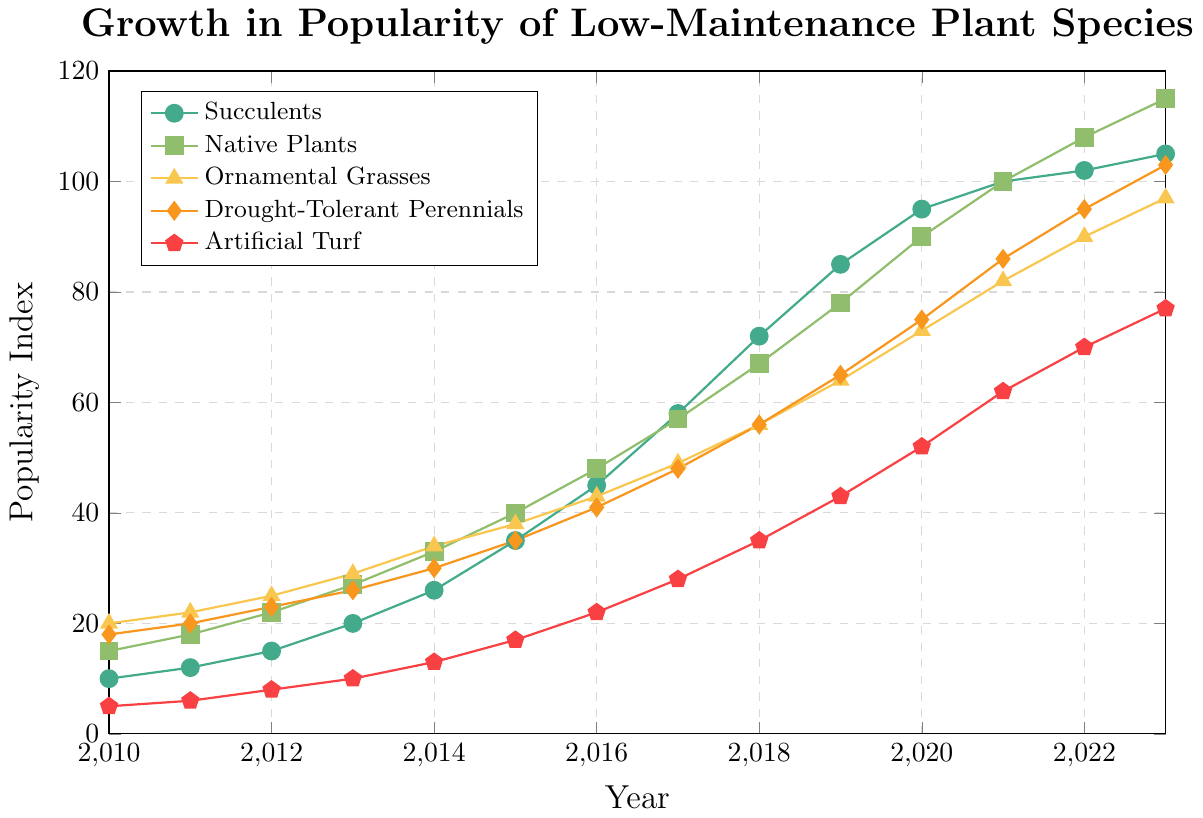Which plant species had the highest popularity index in 2023? Look at the values for 2023 for each species and compare their popularity indices. Native Plants have the highest index at 115.
Answer: Native Plants How did the popularity of Succulents change from 2010 to 2023? Subtract the 2010 popularity index from the 2023 value: 105 - 10 = 95.
Answer: Increased by 95 Which plant species had the least growth in popularity from 2010 to 2023? Calculate the change for each species and compare. Succulents: 105-10=95, Native Plants: 115-15=100, Ornamental Grasses: 97-20=77, Drought-Tolerant Perennials: 103-18=85, Artificial Turf: 77-5=72. Artificial Turf had the smallest growth.
Answer: Artificial Turf What is the average popularity of Drought-Tolerant Perennials from 2010 to 2023? Add up the values from all years and divide by the number of years (14): (18+20+23+26+30+35+41+48+56+65+75+86+95+103)/14 = 49.6.
Answer: 49.6 During which year did Native Plants surpass a popularity index of 50? Look at the values for Native Plants and find the first year where the index is above 50. In 2016, the index is 48, and in 2017, it is 57.
Answer: 2017 Which species showed the steepest increase between 2015 and 2016? Calculate the change for each species between 2015 and 2016: Succulents: 45-35=10, Native Plants: 48-40=8, Ornamental Grasses: 43-38=5, Drought-Tolerant Perennials: 41-35=6, Artificial Turf: 22-17=5. Succulents have the largest increase.
Answer: Succulents From 2010 to 2023, which year had the highest overall increase in popularity index for all species combined? Calculate the sum of increases for all species for each year and identify the highest. 
For example, between 2010 and 2011: (12-10) + (18-15) + (22-20) + (20-18) + (6-5) = 3 + 3 + 2 + 2 + 1 = 11.
Repeat this for all years and find the highest sum.
Between 2016 and 2017: 13 + 9 + 6 + 7 + 6 = 41.
Answer: 2016-2017 What is the combined popularity index of all species in 2010? Add the popularity indices for all species in 2010: 10 + 15 + 20 + 18 + 5 = 68.
Answer: 68 Which species had the most consistent growth from 2010 to 2023, based on visual analysis? Visually assess the steadiness of the slopes for each species across years. Succulents show a steady, consistent increase without sudden spikes or dips.
Answer: Succulents 